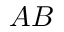<formula> <loc_0><loc_0><loc_500><loc_500>A B</formula> 